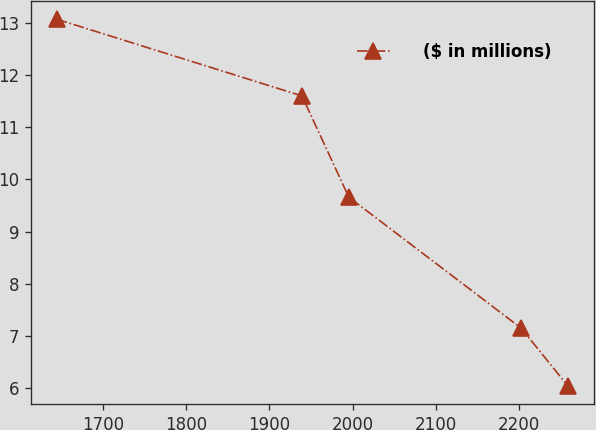Convert chart. <chart><loc_0><loc_0><loc_500><loc_500><line_chart><ecel><fcel>($ in millions)<nl><fcel>1644.71<fcel>13.07<nl><fcel>1939.16<fcel>11.6<nl><fcel>1995.41<fcel>9.66<nl><fcel>2202.34<fcel>7.15<nl><fcel>2258.59<fcel>6.04<nl></chart> 